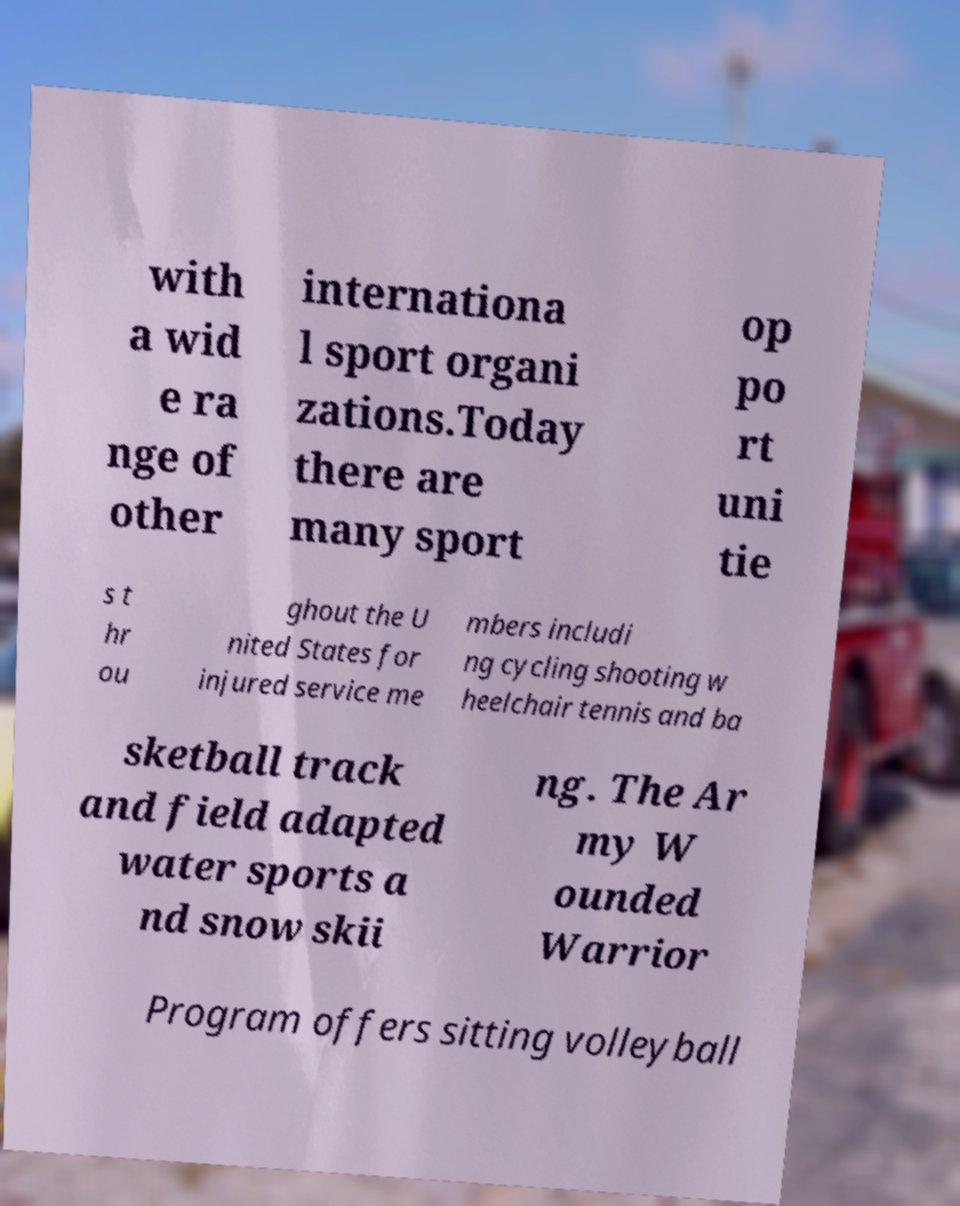There's text embedded in this image that I need extracted. Can you transcribe it verbatim? with a wid e ra nge of other internationa l sport organi zations.Today there are many sport op po rt uni tie s t hr ou ghout the U nited States for injured service me mbers includi ng cycling shooting w heelchair tennis and ba sketball track and field adapted water sports a nd snow skii ng. The Ar my W ounded Warrior Program offers sitting volleyball 